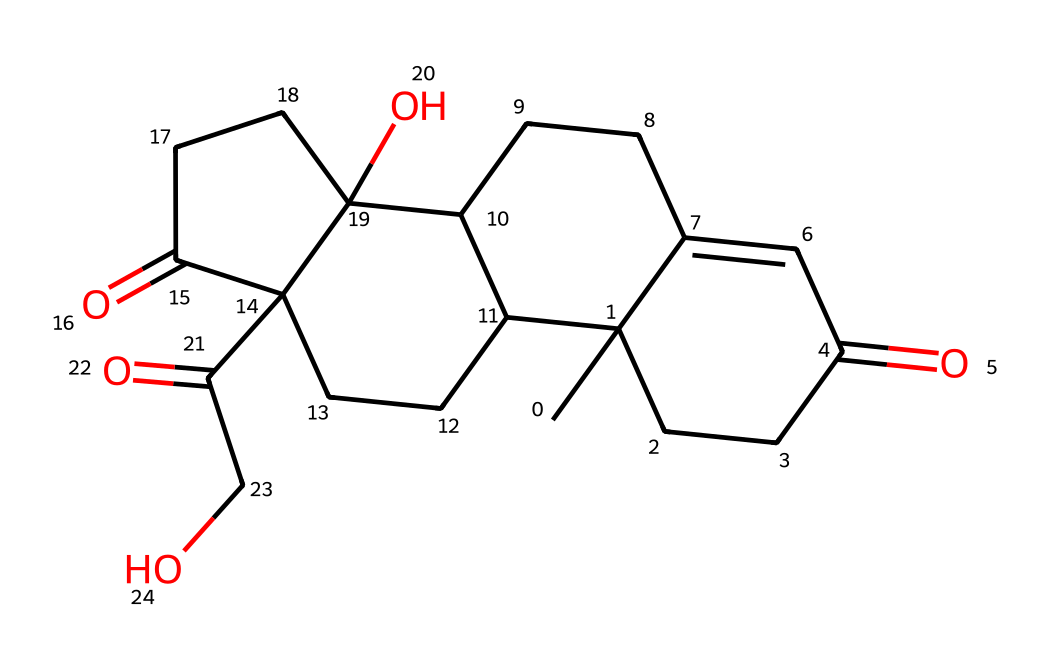What is the molecular formula of cortisol? By analyzing the structure based on the SMILES representation, we can count the types of atoms present. The structure contains 21 carbons (C), 30 hydrogens (H), and 5 oxygens (O). Combining these gives the molecular formula C21H30O5.
Answer: C21H30O5 How many rings are present in cortisol? The structure reveals that there are four interconnected rings observed through the cyclic nature of the carbon atoms in the SMILES representation. By visually inspecting the structure described, we can conclude that there are four rings.
Answer: 4 What type of functional groups does cortisol have? From the SMILES, there are multiple carbonyl (C=O) groups and a hydroxyl (OH) group visible in the structure. These functional groups can be identified based on their typical bonding and placements within the cyclic structure.
Answer: ketone and alcohol How many double bonds are there in cortisol? In the provided structure, we can identify two instances of double bonds in the chain by examining the connections between carbon atoms. Counting these gives us a total of two double bonds.
Answer: 2 What is the significance of cortisol in crowd dynamics? Cortisol is a stress hormone that can be elevated in crowded situations, influencing behavior and physiological responses. Its role is critical in understanding how individuals react to stress within a crowd, which can impact safety and crowd dynamics.
Answer: stress response What is the structural feature that defines cortisol as a steroid? Cortisol has a specific arrangement of four fused carbon rings, which is typical for steroid hormones. This characteristic ring structure differentiates it structurally from other types of hormones and classes of compounds.
Answer: four fused rings 